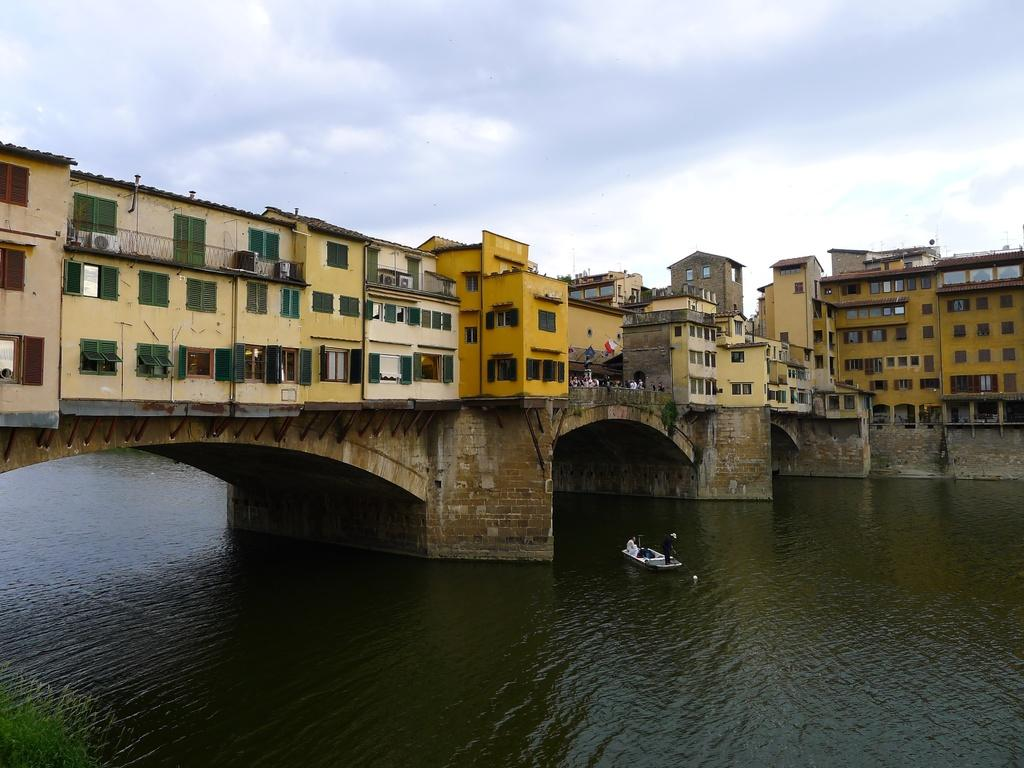What is the main subject of the image? The main subject of the image is buildings on a bridge. What can be seen below the bridge in the image? There is water visible in the image, and a boat is in the water. What is visible at the top of the image? The sky is visible at the top of the image. Can you see a rabbit in the picture? There is no rabbit present in the image. What type of tooth is visible in the image? There are no teeth present in the image. 